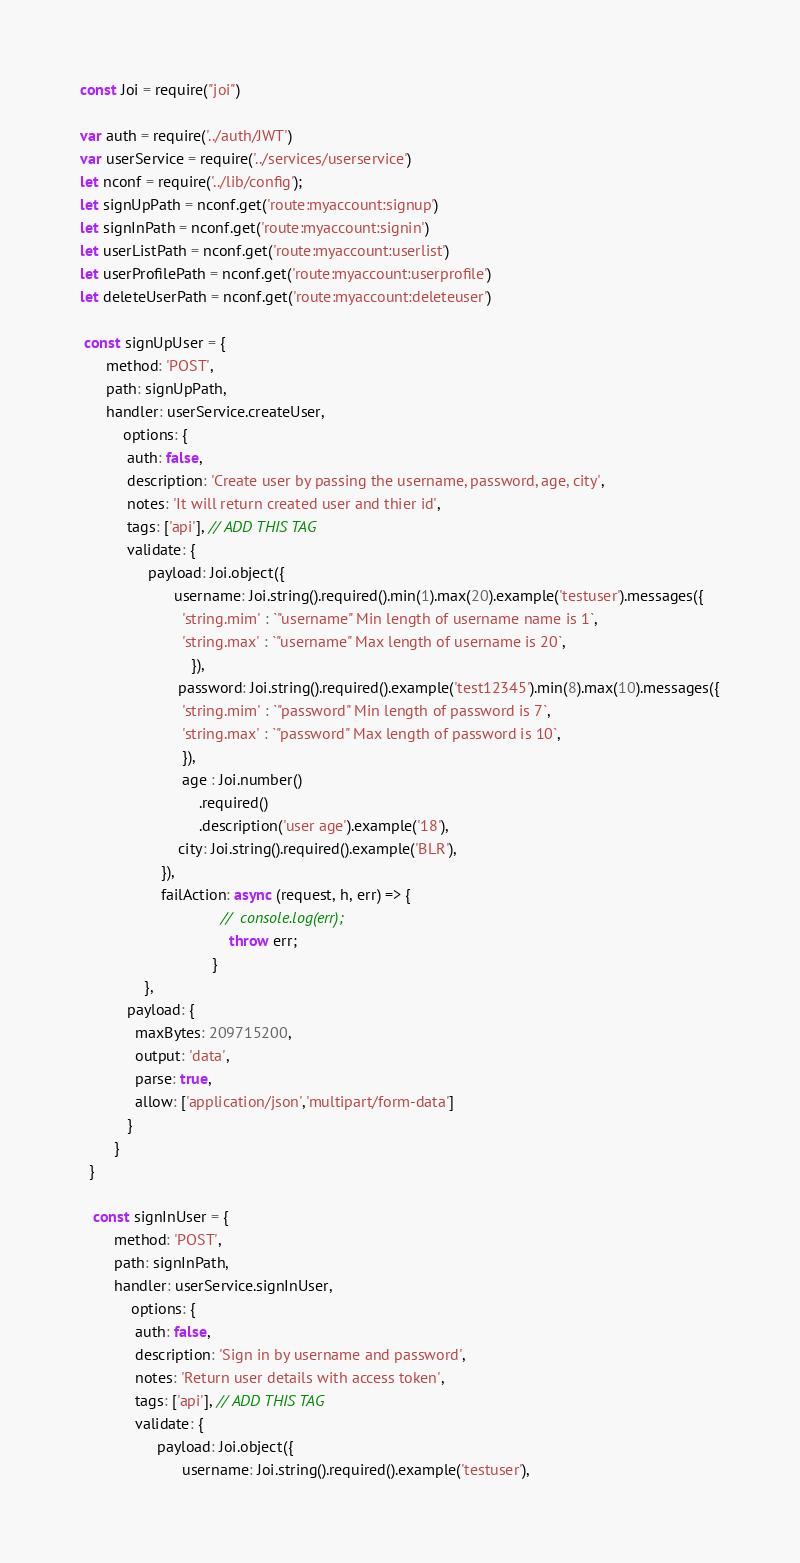<code> <loc_0><loc_0><loc_500><loc_500><_JavaScript_>
const Joi = require("joi")

var auth = require('../auth/JWT')
var userService = require('../services/userservice')
let nconf = require('../lib/config');
let signUpPath = nconf.get('route:myaccount:signup')
let signInPath = nconf.get('route:myaccount:signin')
let userListPath = nconf.get('route:myaccount:userlist')
let userProfilePath = nconf.get('route:myaccount:userprofile')
let deleteUserPath = nconf.get('route:myaccount:deleteuser')

 const signUpUser = {
      method: 'POST',
      path: signUpPath,
      handler: userService.createUser,
          options: {
           auth: false,
           description: 'Create user by passing the username, password, age, city',
           notes: 'It will return created user and thier id',
           tags: ['api'], // ADD THIS TAG
           validate: {
                payload: Joi.object({
                      username: Joi.string().required().min(1).max(20).example('testuser').messages({
                        'string.mim' : `"username" Min length of username name is 1`,
                        'string.max' : `"username" Max length of username is 20`,
                          }),
                       password: Joi.string().required().example('test12345').min(8).max(10).messages({
                        'string.mim' : `"password" Min length of password is 7`,
                        'string.max' : `"password" Max length of password is 10`,
                        }),
                        age : Joi.number()
                            .required()
                            .description('user age').example('18'),
                       city: Joi.string().required().example('BLR'),
                   }),
                   failAction: async (request, h, err) => {
                                 //  console.log(err);
                                   throw err;
                               }
               },
           payload: {
             maxBytes: 209715200,
             output: 'data',
             parse: true,
             allow: ['application/json','multipart/form-data']
           }
        }
  }

   const signInUser = {
        method: 'POST',
        path: signInPath,
        handler: userService.signInUser,
            options: {
             auth: false,
             description: 'Sign in by username and password',
             notes: 'Return user details with access token',
             tags: ['api'], // ADD THIS TAG
             validate: {
                  payload: Joi.object({
                        username: Joi.string().required().example('testuser'),</code> 